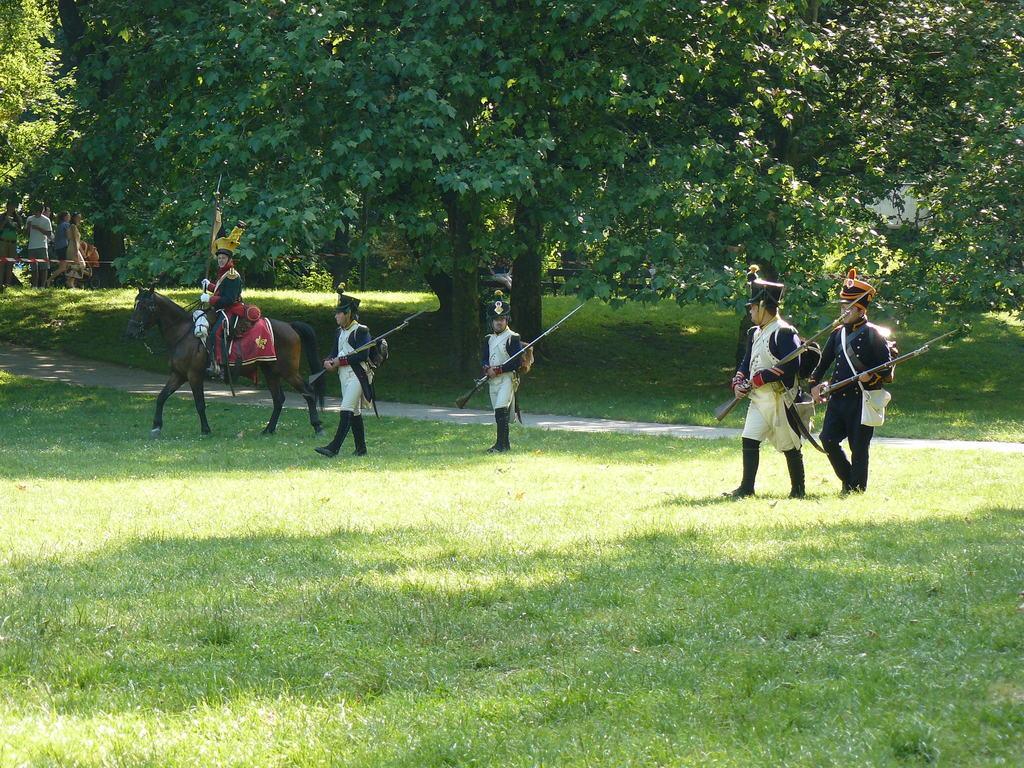Could you give a brief overview of what you see in this image? In the picture we can see some people are standing with a costume and holding the guns and beside them, we can see a person riding the horse and behind them, we can see a pathway and behind it also we can see the part of the grass surface with trees and near it we can see three people are standing near it. 